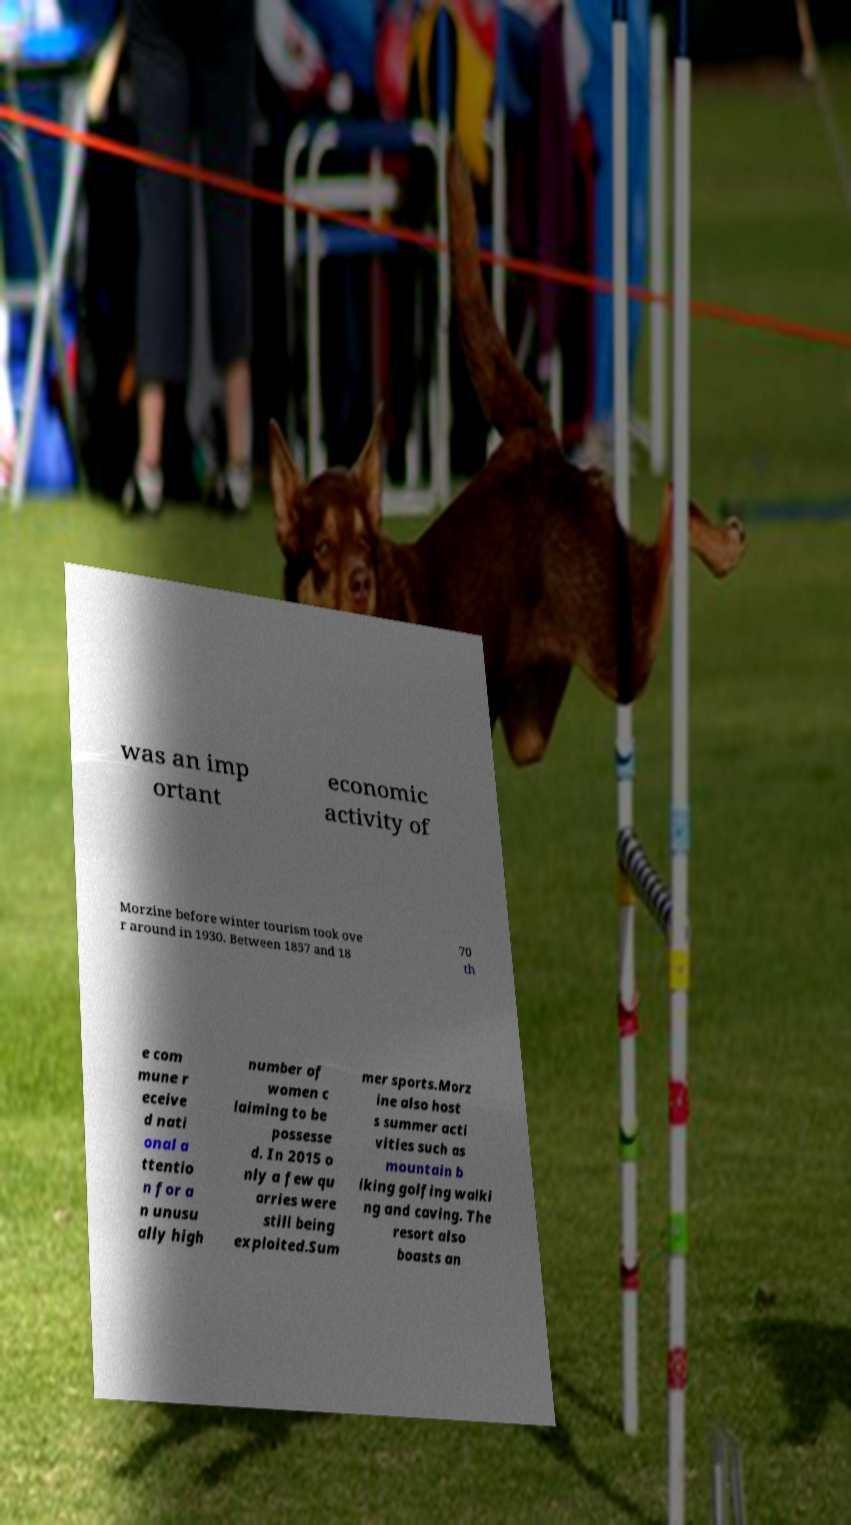Can you read and provide the text displayed in the image?This photo seems to have some interesting text. Can you extract and type it out for me? was an imp ortant economic activity of Morzine before winter tourism took ove r around in 1930. Between 1857 and 18 70 th e com mune r eceive d nati onal a ttentio n for a n unusu ally high number of women c laiming to be possesse d. In 2015 o nly a few qu arries were still being exploited.Sum mer sports.Morz ine also host s summer acti vities such as mountain b iking golfing walki ng and caving. The resort also boasts an 